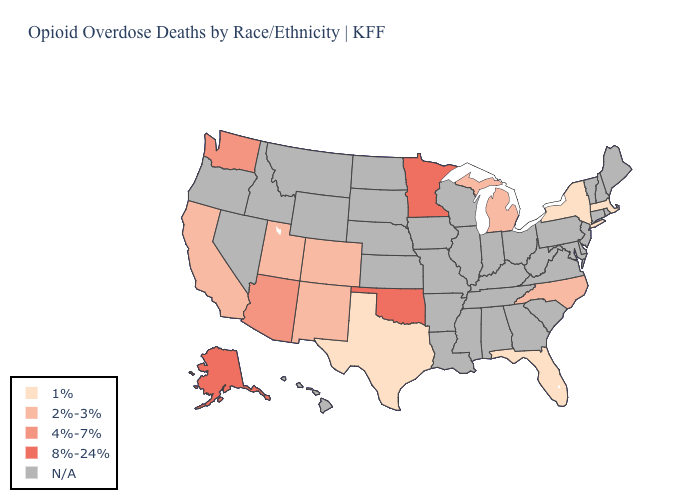What is the lowest value in states that border South Carolina?
Keep it brief. 2%-3%. Among the states that border Pennsylvania , which have the highest value?
Concise answer only. New York. How many symbols are there in the legend?
Short answer required. 5. Does Oklahoma have the highest value in the South?
Short answer required. Yes. Which states have the lowest value in the USA?
Write a very short answer. Florida, Massachusetts, New York, Texas. What is the value of Michigan?
Give a very brief answer. 2%-3%. Name the states that have a value in the range 4%-7%?
Keep it brief. Arizona, Washington. Name the states that have a value in the range 4%-7%?
Short answer required. Arizona, Washington. What is the highest value in the USA?
Concise answer only. 8%-24%. Does the first symbol in the legend represent the smallest category?
Write a very short answer. Yes. What is the value of Wyoming?
Keep it brief. N/A. Which states hav the highest value in the Northeast?
Give a very brief answer. Massachusetts, New York. Is the legend a continuous bar?
Quick response, please. No. 